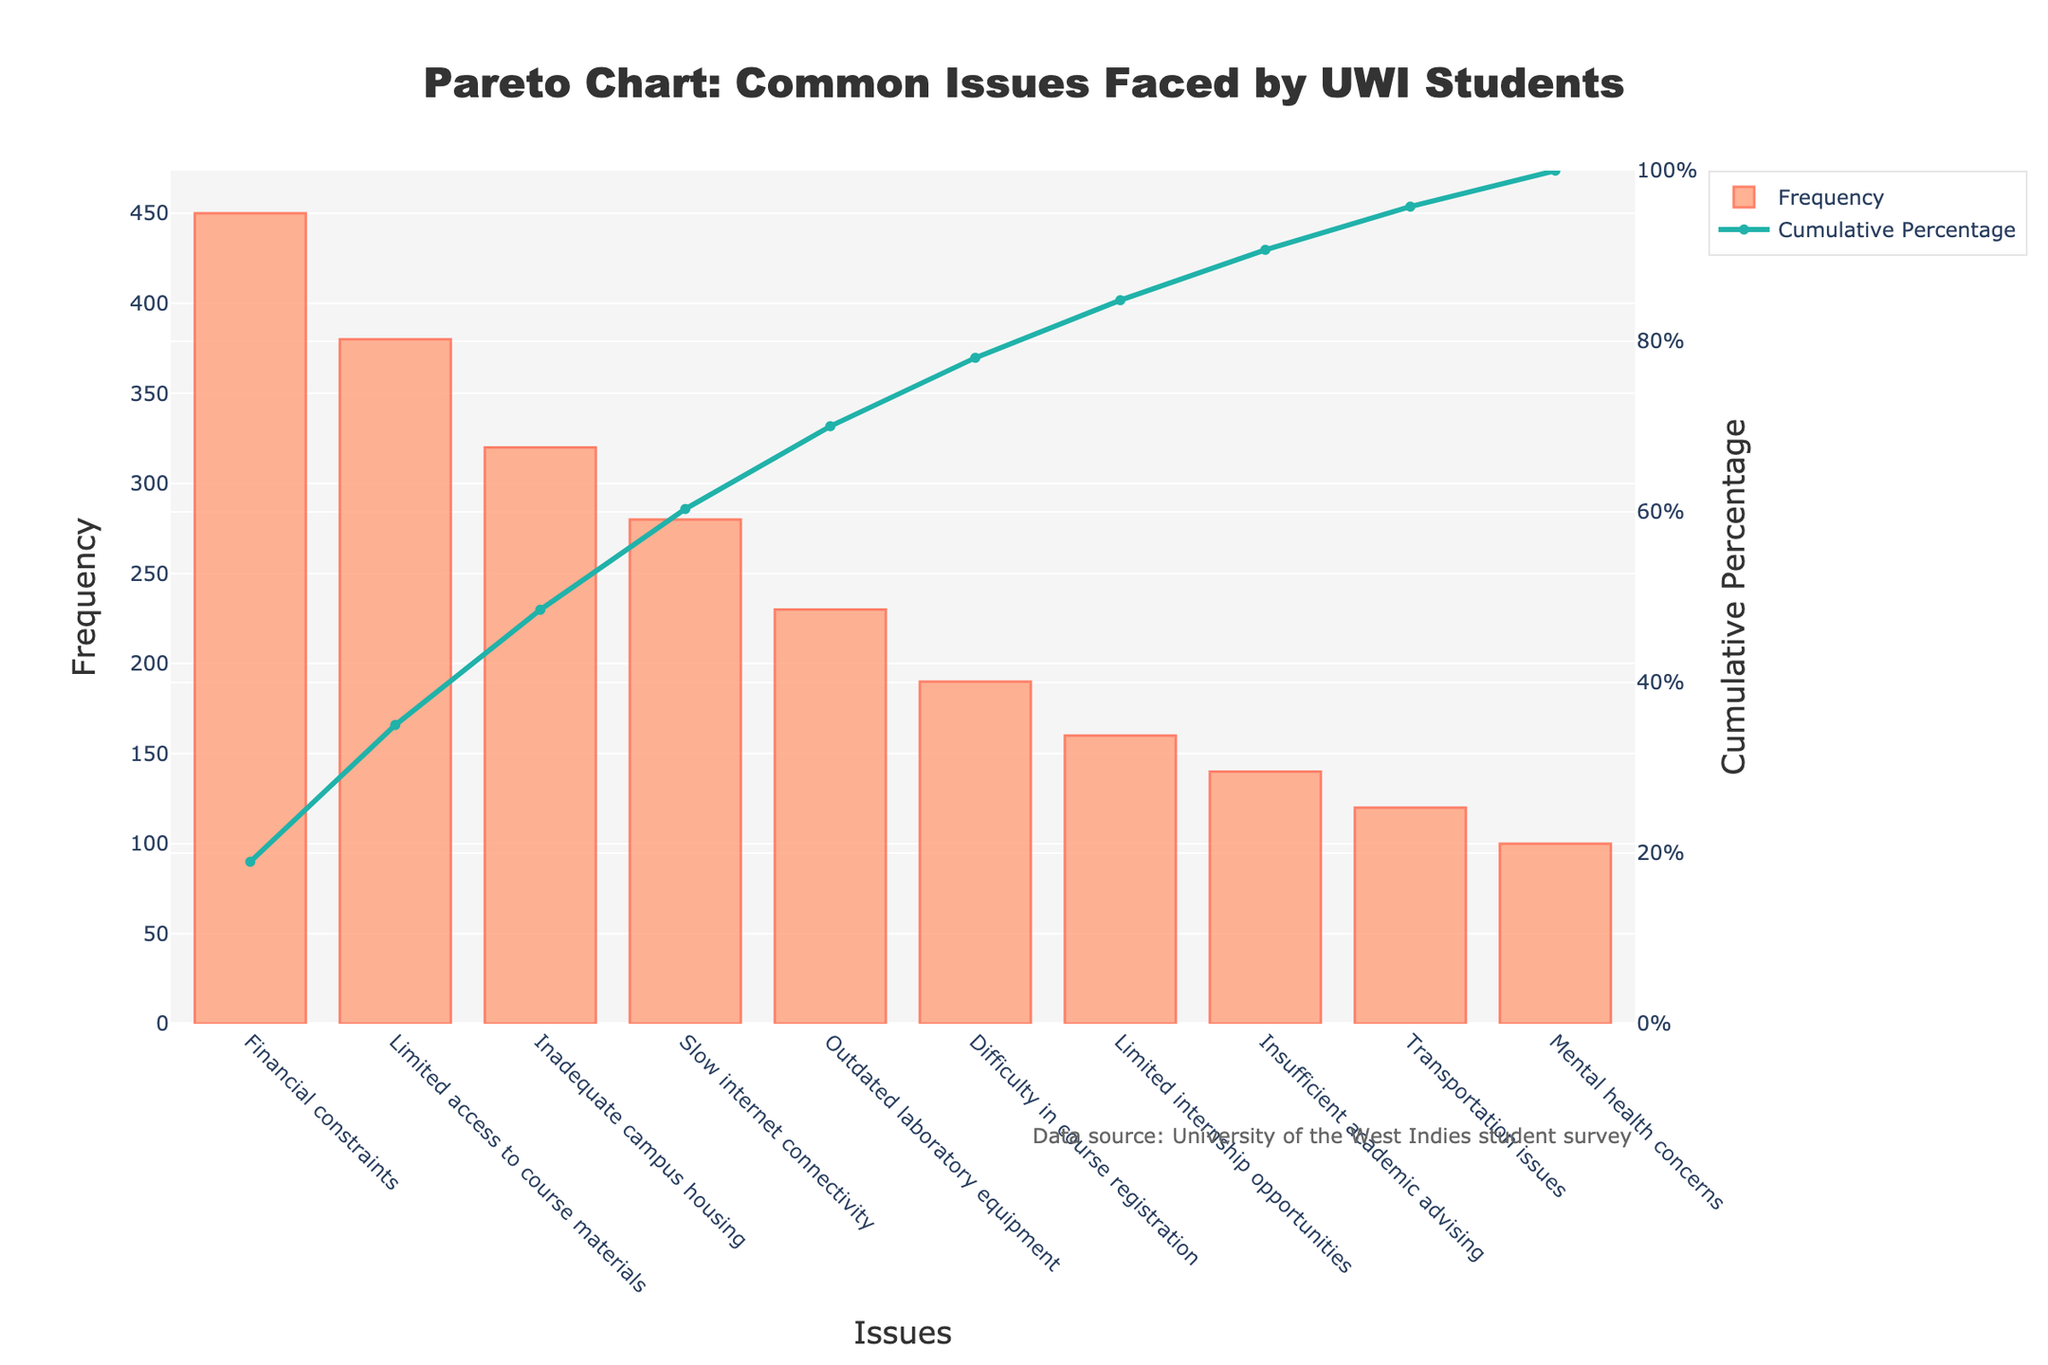What is the title of the Pareto chart? The title is a short descriptor usually located at the top of the figure. In this chart, the title reads "Pareto Chart: Common Issues Faced by UWI Students."
Answer: Pareto Chart: Common Issues Faced by UWI Students Which issue has the highest frequency of occurrence according to the chart? The issue with the highest frequency of occurrence has the tallest bar. In this chart, "Financial constraints" has the highest bar.
Answer: Financial constraints How many issues have a frequency higher than 300? To find this, we need to count the number of bars that have a height corresponding to a frequency higher than 300. "Financial constraints" (450), "Limited access to course materials" (380), and "Inadequate campus housing" (320) are the only issues.
Answer: 3 What is the cumulative percentage of the top three issues combined? The cumulative percentages of the top three issues ("Financial constraints," "Limited access to course materials," and "Inadequate campus housing") are summed up. They are approximately 31%, 57%, and 79%. Adding these gives us 79%.
Answer: 79% Which issue corresponds to the steepest increase in cumulative percentage? The steepest increase typically occurs with the largest frequency, especially at the beginning. Here, "Financial constraints" cause the steepest increase from 0% to 31%.
Answer: Financial constraints What color represents the bars in the chart? The bars are colored in a specific hue that stands out. Here, it is described as a shade between light and dark orange.
Answer: Light orange to dark orange What is the total frequency of all issues combined? Adding the frequencies of all issues (450+380+320+280+230+190+160+140+120+100), we get the total frequency.
Answer: 2370 What is the frequency for the issue "Mental health concerns"? The frequency can be directly inferred from the bar labeled "Mental health concerns", which reads 100.
Answer: 100 What is the cumulative percentage contributed by "Transportation issues"? The cumulative percentage of "Transportation issues" can be seen as a point on the secondary (right) y-axis corresponding to this bar, which reads approximately 95%.
Answer: 95% Which issue has the lowest contribution to the overall cumulative percentage? The issue with the lowest frequency will have the smallest bar, corresponding to "Mental health concerns".
Answer: Mental health concerns 